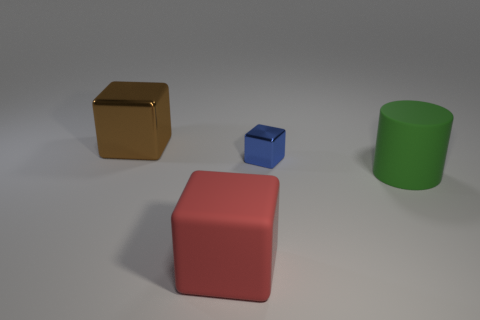What number of tiny things are either yellow spheres or green cylinders?
Your answer should be compact. 0. Are there any other things that are the same color as the matte block?
Make the answer very short. No. There is a large green cylinder; are there any blue metal things on the right side of it?
Keep it short and to the point. No. How big is the rubber object left of the metal block that is in front of the brown block?
Offer a very short reply. Large. Are there the same number of metal cubes behind the tiny blue object and matte things to the left of the large brown cube?
Keep it short and to the point. No. There is a rubber thing in front of the green cylinder; are there any big brown objects on the right side of it?
Provide a short and direct response. No. There is a thing that is to the left of the big matte object that is in front of the cylinder; how many blue shiny objects are behind it?
Your answer should be compact. 0. Are there fewer tiny blue things than matte objects?
Give a very brief answer. Yes. Is the shape of the rubber thing on the left side of the blue shiny block the same as the metallic object that is to the left of the tiny metallic thing?
Provide a short and direct response. Yes. What is the color of the small block?
Your response must be concise. Blue. 